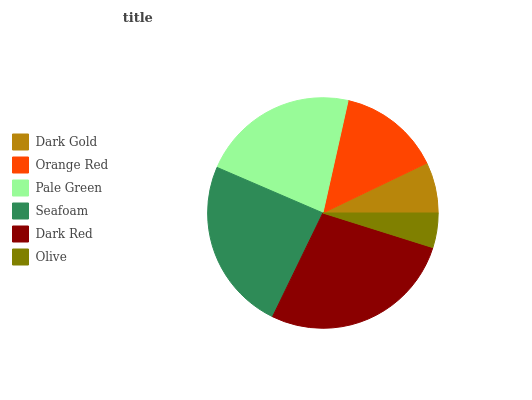Is Olive the minimum?
Answer yes or no. Yes. Is Dark Red the maximum?
Answer yes or no. Yes. Is Orange Red the minimum?
Answer yes or no. No. Is Orange Red the maximum?
Answer yes or no. No. Is Orange Red greater than Dark Gold?
Answer yes or no. Yes. Is Dark Gold less than Orange Red?
Answer yes or no. Yes. Is Dark Gold greater than Orange Red?
Answer yes or no. No. Is Orange Red less than Dark Gold?
Answer yes or no. No. Is Pale Green the high median?
Answer yes or no. Yes. Is Orange Red the low median?
Answer yes or no. Yes. Is Dark Gold the high median?
Answer yes or no. No. Is Dark Gold the low median?
Answer yes or no. No. 